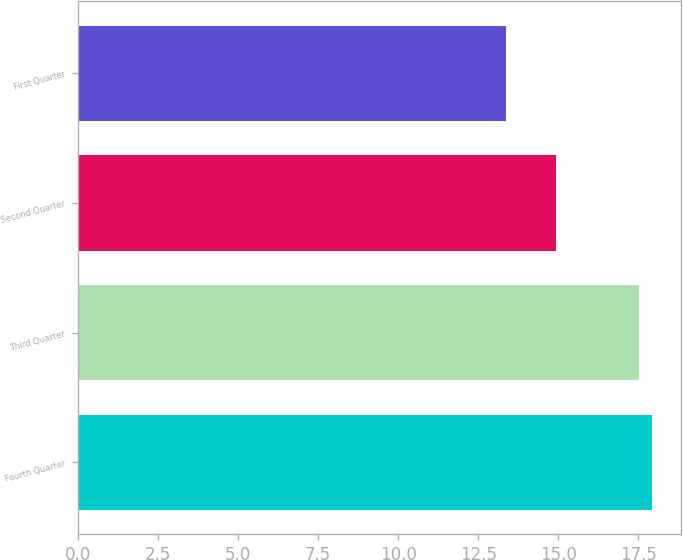Convert chart. <chart><loc_0><loc_0><loc_500><loc_500><bar_chart><fcel>Fourth Quarter<fcel>Third Quarter<fcel>Second Quarter<fcel>First Quarter<nl><fcel>17.94<fcel>17.51<fcel>14.94<fcel>13.38<nl></chart> 